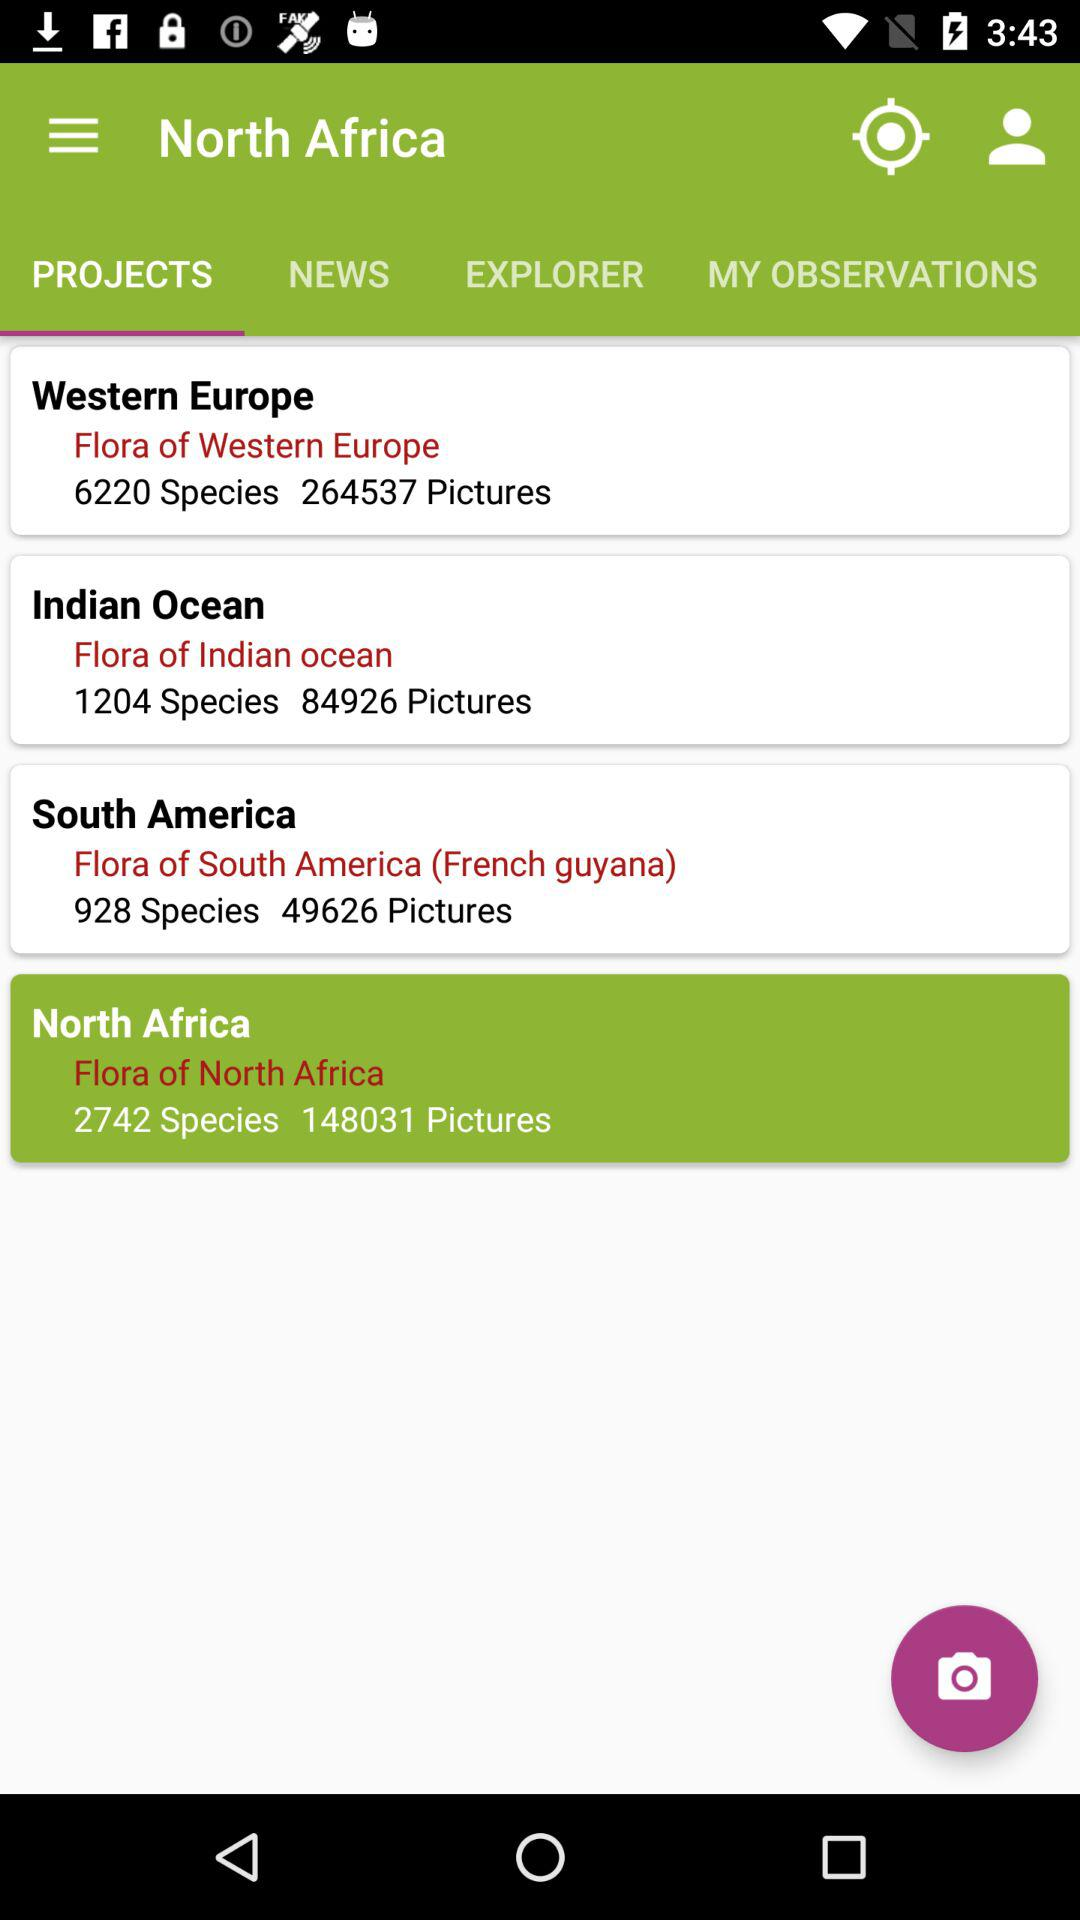What is the count of pictures in "Flora of South America (French guyana)"? The count of pictures in "Flora of South America (French guyana)" is 49626. 